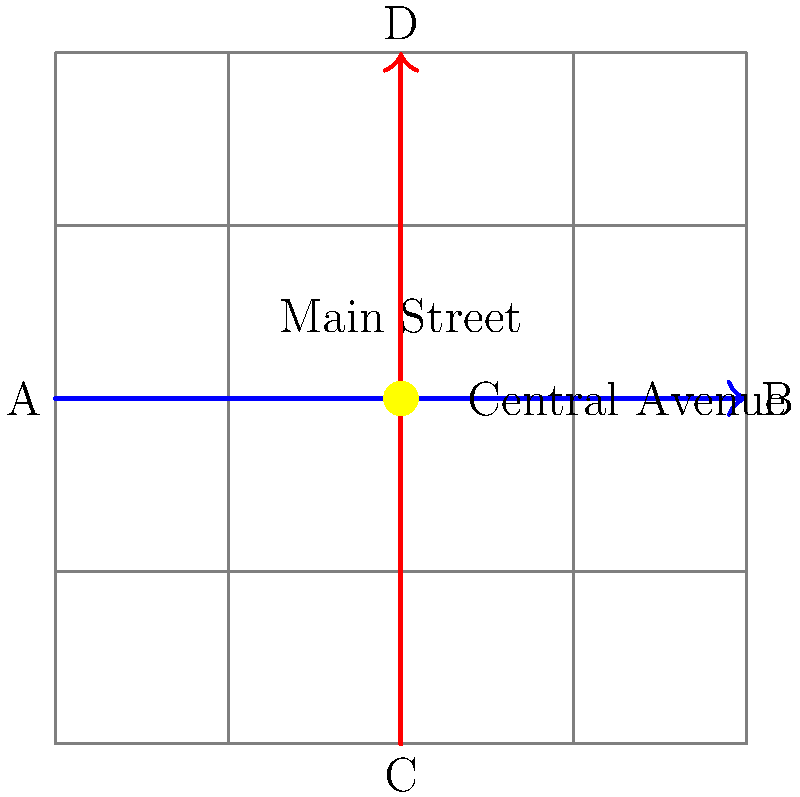In the urban grid shown above, Main Street (blue) and Central Avenue (red) intersect at a crucial junction. Given that both streets have equal importance in the city's traffic flow, what urban planning strategy would you recommend to optimize traffic flow and minimize congestion at this intersection, considering the potential socio-economic impacts on the surrounding neighborhoods? To answer this question, we need to consider several factors:

1. Traffic flow optimization: The intersection of two major streets often leads to congestion, especially during peak hours.

2. Socio-economic impacts: Any changes to the traffic pattern can affect local businesses and residents.

3. Urban planning strategies: Several options are available, each with its own pros and cons:

   a) Traffic light system: Traditional but can cause delays.
   b) Roundabout: Improves flow but requires more space.
   c) Grade separation: Efficient but expensive and can divide neighborhoods.
   d) Smart traffic management: Uses technology to optimize flow.

4. Political considerations: The chosen solution must be politically viable and consider public opinion.

5. Historical context: Understanding how past urban planning decisions have affected the city's development.

Considering these factors, a balanced approach would be to implement a smart traffic management system. This solution:

- Optimizes traffic flow using real-time data and AI algorithms.
- Minimizes physical changes to the urban landscape, preserving neighborhood character.
- Is cost-effective compared to major infrastructure projects.
- Can be adjusted based on changing traffic patterns and public feedback.
- Aligns with modern urban planning principles of sustainability and adaptability.

This approach also allows for a critical examination of how technology-driven solutions compare to historical urban planning strategies, which often favored more invasive infrastructure projects.
Answer: Implement a smart traffic management system 